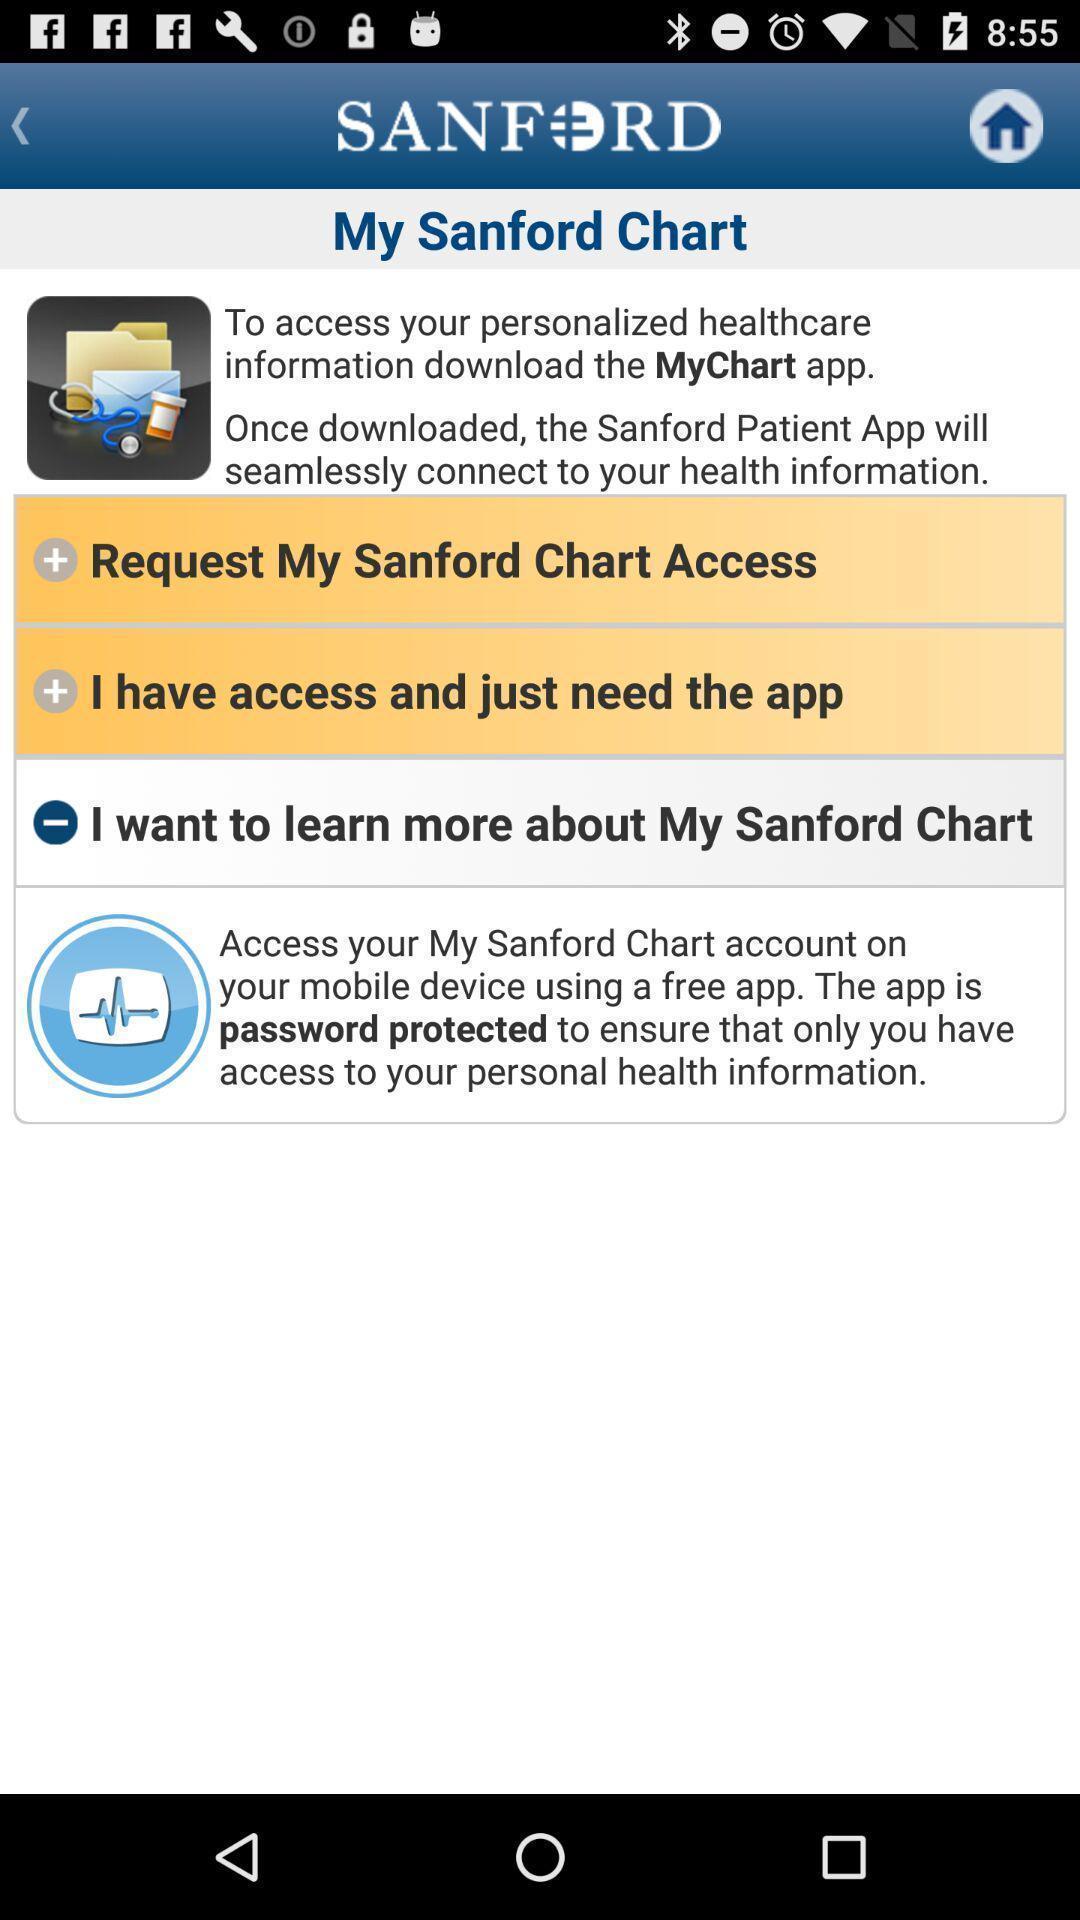Tell me about the visual elements in this screen capture. Page that displaying healthcare application. 